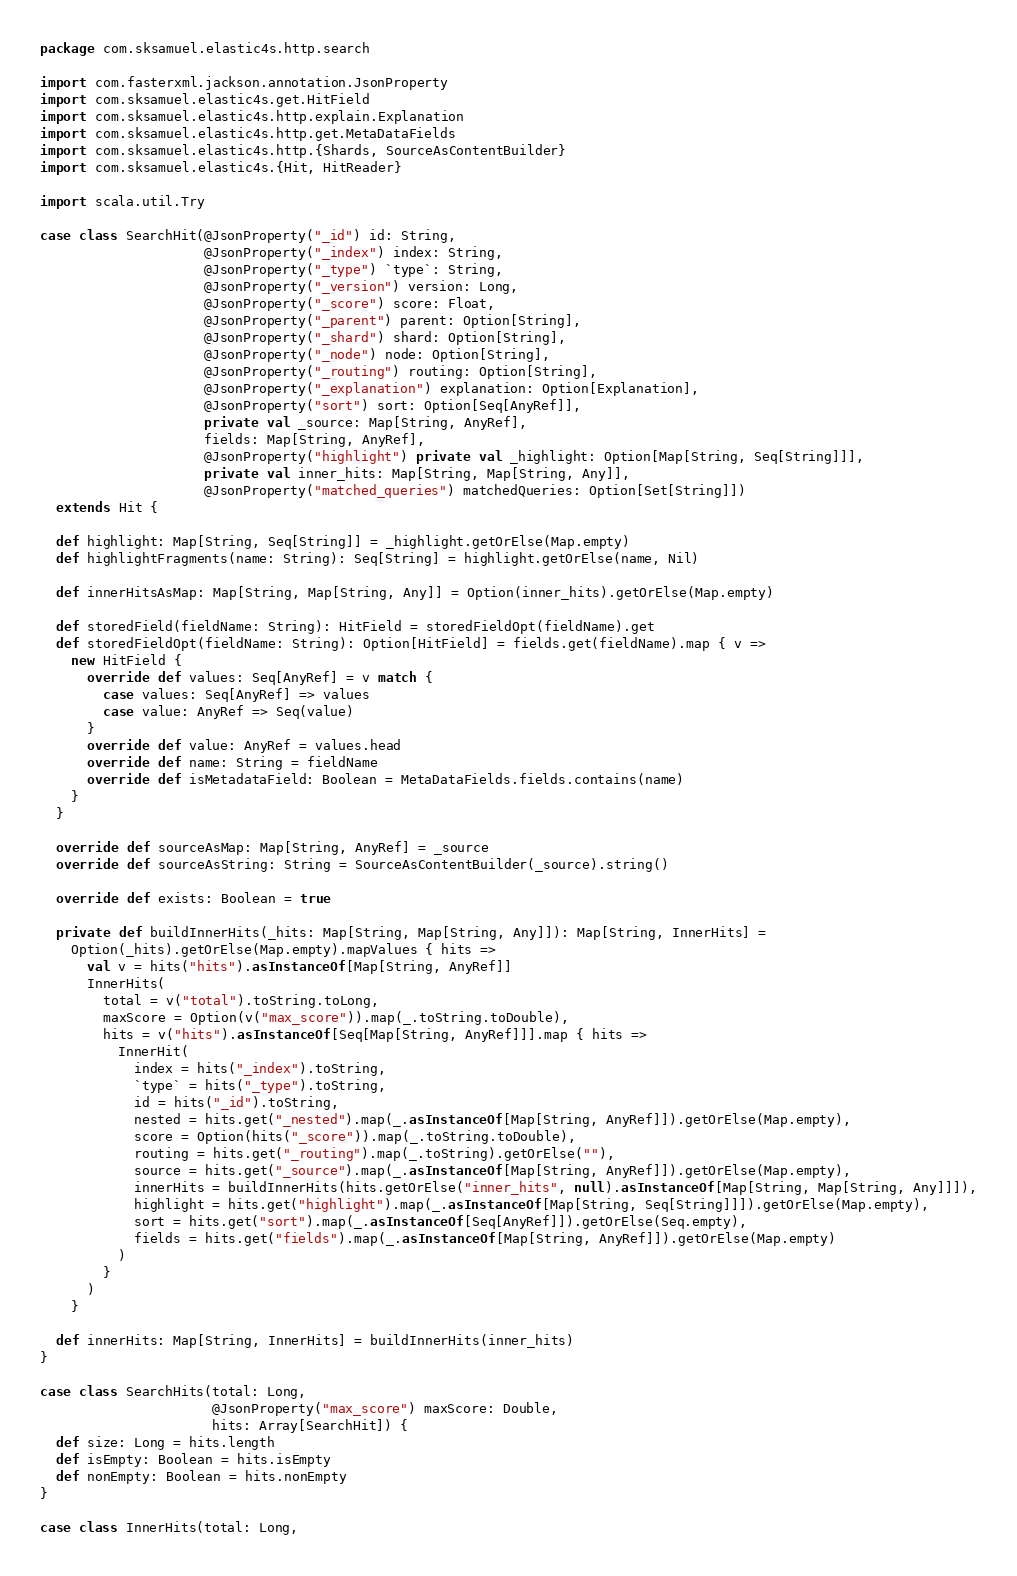Convert code to text. <code><loc_0><loc_0><loc_500><loc_500><_Scala_>package com.sksamuel.elastic4s.http.search

import com.fasterxml.jackson.annotation.JsonProperty
import com.sksamuel.elastic4s.get.HitField
import com.sksamuel.elastic4s.http.explain.Explanation
import com.sksamuel.elastic4s.http.get.MetaDataFields
import com.sksamuel.elastic4s.http.{Shards, SourceAsContentBuilder}
import com.sksamuel.elastic4s.{Hit, HitReader}

import scala.util.Try

case class SearchHit(@JsonProperty("_id") id: String,
                     @JsonProperty("_index") index: String,
                     @JsonProperty("_type") `type`: String,
                     @JsonProperty("_version") version: Long,
                     @JsonProperty("_score") score: Float,
                     @JsonProperty("_parent") parent: Option[String],
                     @JsonProperty("_shard") shard: Option[String],
                     @JsonProperty("_node") node: Option[String],
                     @JsonProperty("_routing") routing: Option[String],
                     @JsonProperty("_explanation") explanation: Option[Explanation],
                     @JsonProperty("sort") sort: Option[Seq[AnyRef]],
                     private val _source: Map[String, AnyRef],
                     fields: Map[String, AnyRef],
                     @JsonProperty("highlight") private val _highlight: Option[Map[String, Seq[String]]],
                     private val inner_hits: Map[String, Map[String, Any]],
                     @JsonProperty("matched_queries") matchedQueries: Option[Set[String]])
  extends Hit {

  def highlight: Map[String, Seq[String]] = _highlight.getOrElse(Map.empty)
  def highlightFragments(name: String): Seq[String] = highlight.getOrElse(name, Nil)

  def innerHitsAsMap: Map[String, Map[String, Any]] = Option(inner_hits).getOrElse(Map.empty)

  def storedField(fieldName: String): HitField = storedFieldOpt(fieldName).get
  def storedFieldOpt(fieldName: String): Option[HitField] = fields.get(fieldName).map { v =>
    new HitField {
      override def values: Seq[AnyRef] = v match {
        case values: Seq[AnyRef] => values
        case value: AnyRef => Seq(value)
      }
      override def value: AnyRef = values.head
      override def name: String = fieldName
      override def isMetadataField: Boolean = MetaDataFields.fields.contains(name)
    }
  }

  override def sourceAsMap: Map[String, AnyRef] = _source
  override def sourceAsString: String = SourceAsContentBuilder(_source).string()

  override def exists: Boolean = true

  private def buildInnerHits(_hits: Map[String, Map[String, Any]]): Map[String, InnerHits] =
    Option(_hits).getOrElse(Map.empty).mapValues { hits =>
      val v = hits("hits").asInstanceOf[Map[String, AnyRef]]
      InnerHits(
        total = v("total").toString.toLong,
        maxScore = Option(v("max_score")).map(_.toString.toDouble),
        hits = v("hits").asInstanceOf[Seq[Map[String, AnyRef]]].map { hits =>
          InnerHit(
            index = hits("_index").toString,
            `type` = hits("_type").toString,
            id = hits("_id").toString,
            nested = hits.get("_nested").map(_.asInstanceOf[Map[String, AnyRef]]).getOrElse(Map.empty),
            score = Option(hits("_score")).map(_.toString.toDouble),
            routing = hits.get("_routing").map(_.toString).getOrElse(""),
            source = hits.get("_source").map(_.asInstanceOf[Map[String, AnyRef]]).getOrElse(Map.empty),
            innerHits = buildInnerHits(hits.getOrElse("inner_hits", null).asInstanceOf[Map[String, Map[String, Any]]]),
            highlight = hits.get("highlight").map(_.asInstanceOf[Map[String, Seq[String]]]).getOrElse(Map.empty),
            sort = hits.get("sort").map(_.asInstanceOf[Seq[AnyRef]]).getOrElse(Seq.empty),
            fields = hits.get("fields").map(_.asInstanceOf[Map[String, AnyRef]]).getOrElse(Map.empty)
          )
        }
      )
    }

  def innerHits: Map[String, InnerHits] = buildInnerHits(inner_hits)
}

case class SearchHits(total: Long,
                      @JsonProperty("max_score") maxScore: Double,
                      hits: Array[SearchHit]) {
  def size: Long = hits.length
  def isEmpty: Boolean = hits.isEmpty
  def nonEmpty: Boolean = hits.nonEmpty
}

case class InnerHits(total: Long,</code> 